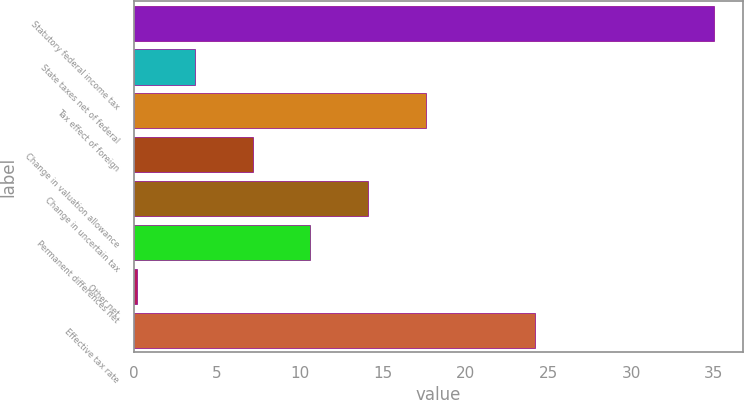Convert chart. <chart><loc_0><loc_0><loc_500><loc_500><bar_chart><fcel>Statutory federal income tax<fcel>State taxes net of federal<fcel>Tax effect of foreign<fcel>Change in valuation allowance<fcel>Change in uncertain tax<fcel>Permanent differences net<fcel>Other net<fcel>Effective tax rate<nl><fcel>35<fcel>3.68<fcel>17.6<fcel>7.16<fcel>14.12<fcel>10.64<fcel>0.2<fcel>24.2<nl></chart> 